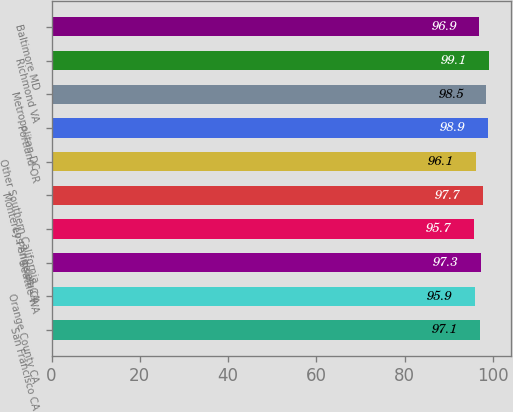Convert chart. <chart><loc_0><loc_0><loc_500><loc_500><bar_chart><fcel>San Francisco CA<fcel>Orange County CA<fcel>Seattle WA<fcel>Los Angeles CA<fcel>Monterey Peninsula CA<fcel>Other Southern California<fcel>Portland OR<fcel>Metropolitan DC<fcel>Richmond VA<fcel>Baltimore MD<nl><fcel>97.1<fcel>95.9<fcel>97.3<fcel>95.7<fcel>97.7<fcel>96.1<fcel>98.9<fcel>98.5<fcel>99.1<fcel>96.9<nl></chart> 